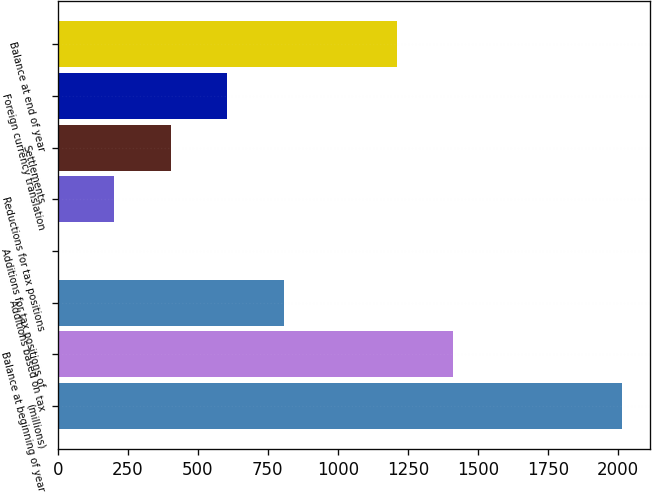Convert chart. <chart><loc_0><loc_0><loc_500><loc_500><bar_chart><fcel>(millions)<fcel>Balance at beginning of year<fcel>Additions based on tax<fcel>Additions for tax positions of<fcel>Reductions for tax positions<fcel>Settlements<fcel>Foreign currency translation<fcel>Balance at end of year<nl><fcel>2015<fcel>1410.77<fcel>806.54<fcel>0.9<fcel>202.31<fcel>403.72<fcel>605.13<fcel>1209.36<nl></chart> 